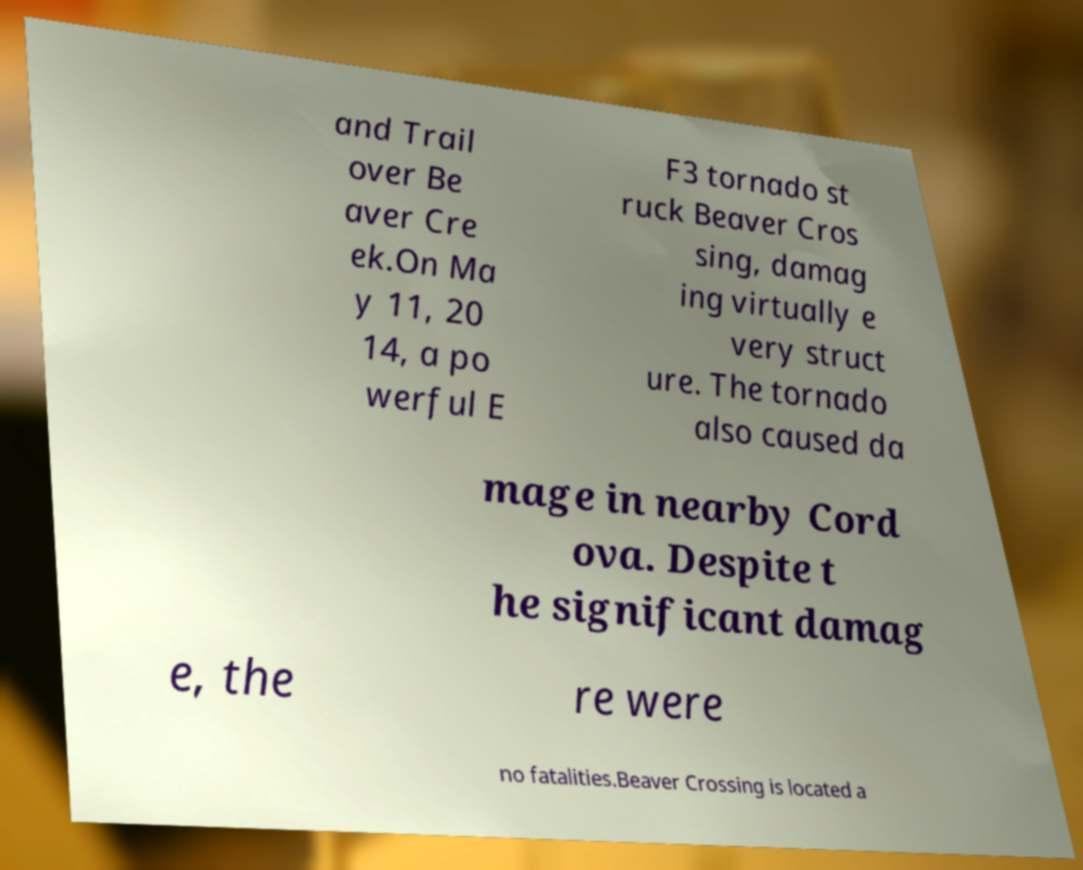Could you extract and type out the text from this image? and Trail over Be aver Cre ek.On Ma y 11, 20 14, a po werful E F3 tornado st ruck Beaver Cros sing, damag ing virtually e very struct ure. The tornado also caused da mage in nearby Cord ova. Despite t he significant damag e, the re were no fatalities.Beaver Crossing is located a 